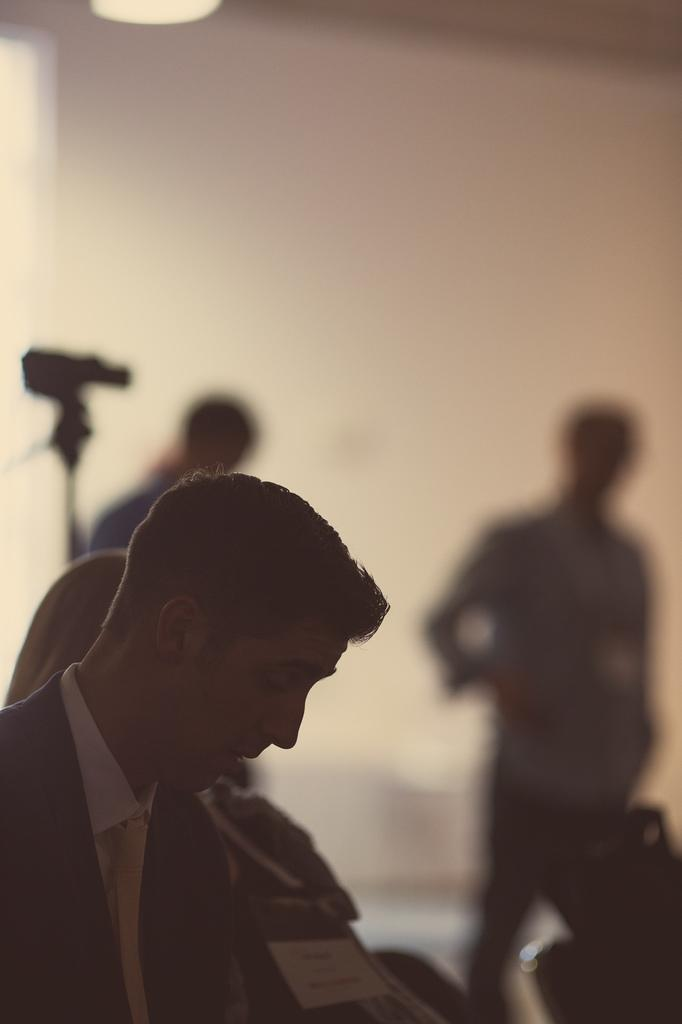Who or what is the main subject in the image? There is a person in the image. What is located behind the person? There is a camera behind the person. Are there any other people in the image? Yes, there are two other people standing beside the camera. What type of amusement can be seen on the plate in the image? There is no plate or amusement present in the image. What kind of shoes are the people wearing in the image? The provided facts do not mention any shoes, so we cannot determine what kind of shoes the people are wearing. 